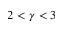<formula> <loc_0><loc_0><loc_500><loc_500>2 < \gamma < 3</formula> 